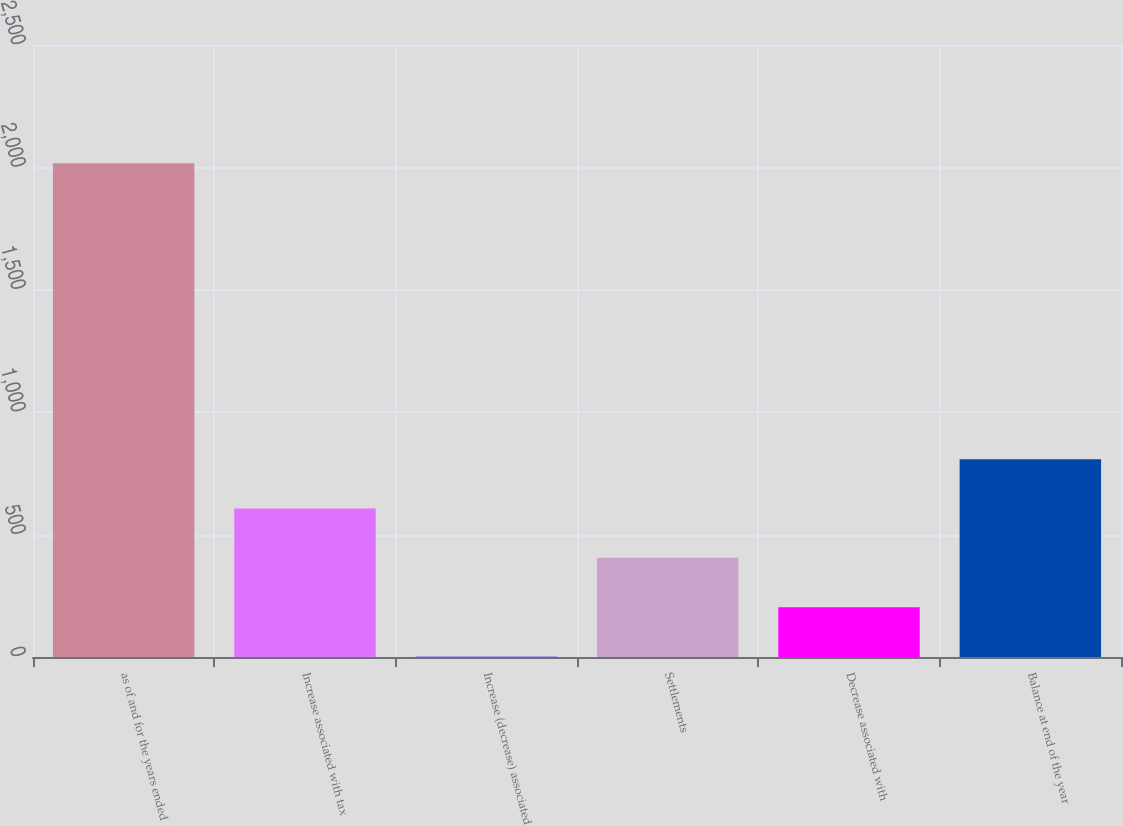Convert chart to OTSL. <chart><loc_0><loc_0><loc_500><loc_500><bar_chart><fcel>as of and for the years ended<fcel>Increase associated with tax<fcel>Increase (decrease) associated<fcel>Settlements<fcel>Decrease associated with<fcel>Balance at end of the year<nl><fcel>2017<fcel>606.5<fcel>2<fcel>405<fcel>203.5<fcel>808<nl></chart> 